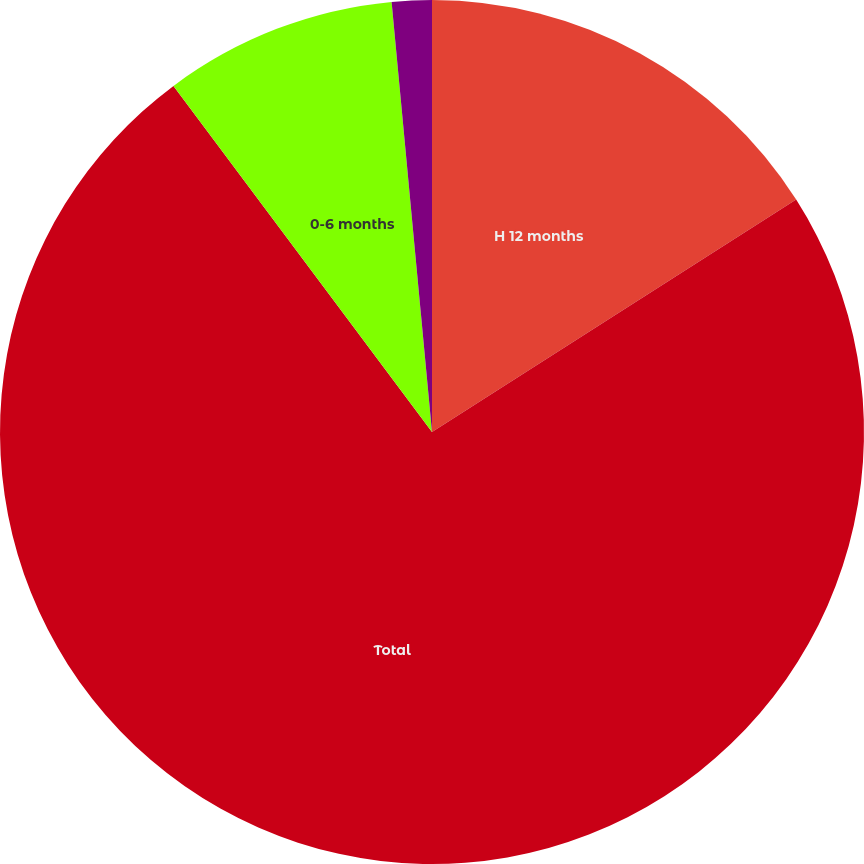Convert chart to OTSL. <chart><loc_0><loc_0><loc_500><loc_500><pie_chart><fcel>H 12 months<fcel>Total<fcel>0-6 months<fcel>7-12 months<nl><fcel>15.96%<fcel>73.83%<fcel>8.72%<fcel>1.49%<nl></chart> 